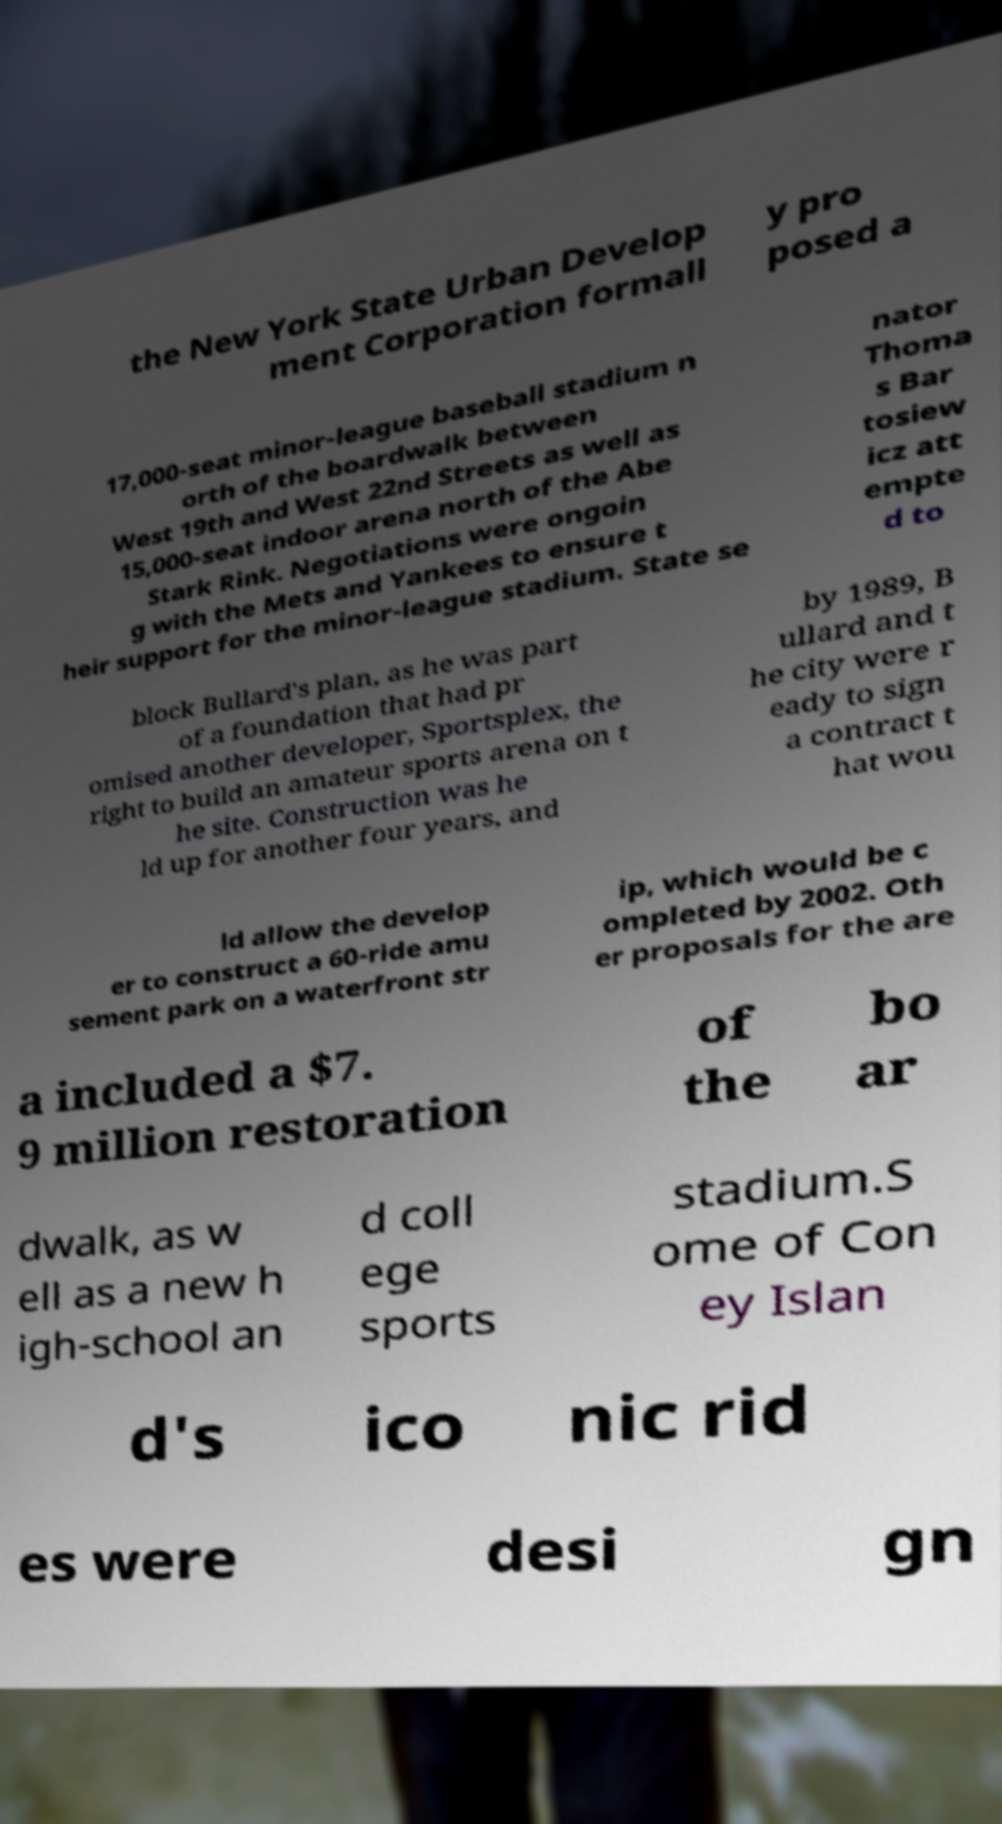Could you extract and type out the text from this image? the New York State Urban Develop ment Corporation formall y pro posed a 17,000-seat minor-league baseball stadium n orth of the boardwalk between West 19th and West 22nd Streets as well as 15,000-seat indoor arena north of the Abe Stark Rink. Negotiations were ongoin g with the Mets and Yankees to ensure t heir support for the minor-league stadium. State se nator Thoma s Bar tosiew icz att empte d to block Bullard's plan, as he was part of a foundation that had pr omised another developer, Sportsplex, the right to build an amateur sports arena on t he site. Construction was he ld up for another four years, and by 1989, B ullard and t he city were r eady to sign a contract t hat wou ld allow the develop er to construct a 60-ride amu sement park on a waterfront str ip, which would be c ompleted by 2002. Oth er proposals for the are a included a $7. 9 million restoration of the bo ar dwalk, as w ell as a new h igh-school an d coll ege sports stadium.S ome of Con ey Islan d's ico nic rid es were desi gn 